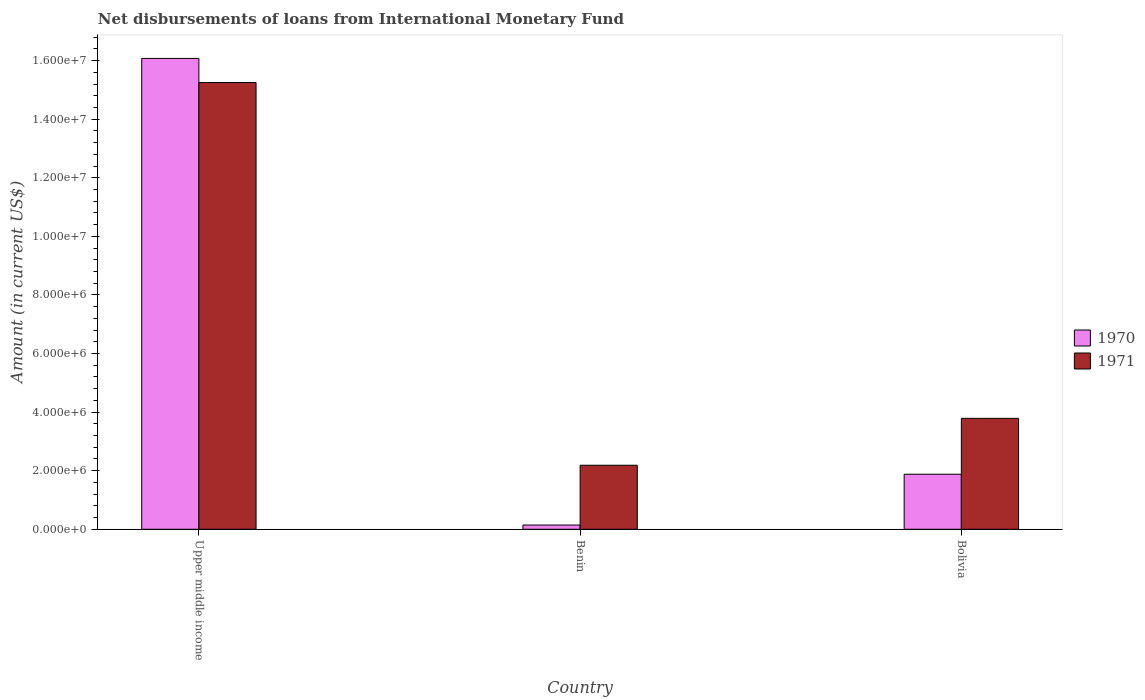How many different coloured bars are there?
Ensure brevity in your answer.  2. How many groups of bars are there?
Your response must be concise. 3. Are the number of bars per tick equal to the number of legend labels?
Keep it short and to the point. Yes. Are the number of bars on each tick of the X-axis equal?
Give a very brief answer. Yes. What is the label of the 3rd group of bars from the left?
Ensure brevity in your answer.  Bolivia. In how many cases, is the number of bars for a given country not equal to the number of legend labels?
Your answer should be compact. 0. What is the amount of loans disbursed in 1971 in Benin?
Make the answer very short. 2.19e+06. Across all countries, what is the maximum amount of loans disbursed in 1971?
Your answer should be compact. 1.52e+07. Across all countries, what is the minimum amount of loans disbursed in 1970?
Offer a terse response. 1.45e+05. In which country was the amount of loans disbursed in 1971 maximum?
Your answer should be compact. Upper middle income. In which country was the amount of loans disbursed in 1970 minimum?
Ensure brevity in your answer.  Benin. What is the total amount of loans disbursed in 1970 in the graph?
Offer a terse response. 1.81e+07. What is the difference between the amount of loans disbursed in 1970 in Bolivia and that in Upper middle income?
Make the answer very short. -1.42e+07. What is the difference between the amount of loans disbursed in 1970 in Upper middle income and the amount of loans disbursed in 1971 in Benin?
Offer a very short reply. 1.39e+07. What is the average amount of loans disbursed in 1970 per country?
Your answer should be very brief. 6.03e+06. What is the difference between the amount of loans disbursed of/in 1970 and amount of loans disbursed of/in 1971 in Bolivia?
Give a very brief answer. -1.91e+06. In how many countries, is the amount of loans disbursed in 1971 greater than 14800000 US$?
Give a very brief answer. 1. What is the ratio of the amount of loans disbursed in 1970 in Benin to that in Upper middle income?
Your response must be concise. 0.01. What is the difference between the highest and the second highest amount of loans disbursed in 1970?
Make the answer very short. 1.59e+07. What is the difference between the highest and the lowest amount of loans disbursed in 1970?
Offer a terse response. 1.59e+07. Is the sum of the amount of loans disbursed in 1971 in Benin and Upper middle income greater than the maximum amount of loans disbursed in 1970 across all countries?
Offer a terse response. Yes. What does the 2nd bar from the right in Bolivia represents?
Give a very brief answer. 1970. How many bars are there?
Give a very brief answer. 6. Are all the bars in the graph horizontal?
Give a very brief answer. No. What is the difference between two consecutive major ticks on the Y-axis?
Offer a terse response. 2.00e+06. Are the values on the major ticks of Y-axis written in scientific E-notation?
Your answer should be compact. Yes. Does the graph contain any zero values?
Your response must be concise. No. How many legend labels are there?
Your response must be concise. 2. What is the title of the graph?
Make the answer very short. Net disbursements of loans from International Monetary Fund. What is the label or title of the X-axis?
Your answer should be very brief. Country. What is the label or title of the Y-axis?
Provide a succinct answer. Amount (in current US$). What is the Amount (in current US$) of 1970 in Upper middle income?
Make the answer very short. 1.61e+07. What is the Amount (in current US$) of 1971 in Upper middle income?
Your answer should be compact. 1.52e+07. What is the Amount (in current US$) in 1970 in Benin?
Ensure brevity in your answer.  1.45e+05. What is the Amount (in current US$) of 1971 in Benin?
Keep it short and to the point. 2.19e+06. What is the Amount (in current US$) in 1970 in Bolivia?
Offer a very short reply. 1.88e+06. What is the Amount (in current US$) in 1971 in Bolivia?
Give a very brief answer. 3.79e+06. Across all countries, what is the maximum Amount (in current US$) of 1970?
Provide a short and direct response. 1.61e+07. Across all countries, what is the maximum Amount (in current US$) in 1971?
Your answer should be compact. 1.52e+07. Across all countries, what is the minimum Amount (in current US$) in 1970?
Offer a very short reply. 1.45e+05. Across all countries, what is the minimum Amount (in current US$) of 1971?
Your response must be concise. 2.19e+06. What is the total Amount (in current US$) of 1970 in the graph?
Make the answer very short. 1.81e+07. What is the total Amount (in current US$) in 1971 in the graph?
Make the answer very short. 2.12e+07. What is the difference between the Amount (in current US$) of 1970 in Upper middle income and that in Benin?
Your answer should be compact. 1.59e+07. What is the difference between the Amount (in current US$) of 1971 in Upper middle income and that in Benin?
Your answer should be compact. 1.31e+07. What is the difference between the Amount (in current US$) of 1970 in Upper middle income and that in Bolivia?
Make the answer very short. 1.42e+07. What is the difference between the Amount (in current US$) in 1971 in Upper middle income and that in Bolivia?
Your answer should be compact. 1.15e+07. What is the difference between the Amount (in current US$) of 1970 in Benin and that in Bolivia?
Your answer should be compact. -1.73e+06. What is the difference between the Amount (in current US$) of 1971 in Benin and that in Bolivia?
Your answer should be very brief. -1.60e+06. What is the difference between the Amount (in current US$) in 1970 in Upper middle income and the Amount (in current US$) in 1971 in Benin?
Your answer should be very brief. 1.39e+07. What is the difference between the Amount (in current US$) of 1970 in Upper middle income and the Amount (in current US$) of 1971 in Bolivia?
Offer a terse response. 1.23e+07. What is the difference between the Amount (in current US$) in 1970 in Benin and the Amount (in current US$) in 1971 in Bolivia?
Give a very brief answer. -3.64e+06. What is the average Amount (in current US$) of 1970 per country?
Provide a succinct answer. 6.03e+06. What is the average Amount (in current US$) in 1971 per country?
Your response must be concise. 7.07e+06. What is the difference between the Amount (in current US$) of 1970 and Amount (in current US$) of 1971 in Upper middle income?
Provide a succinct answer. 8.24e+05. What is the difference between the Amount (in current US$) of 1970 and Amount (in current US$) of 1971 in Benin?
Provide a short and direct response. -2.04e+06. What is the difference between the Amount (in current US$) of 1970 and Amount (in current US$) of 1971 in Bolivia?
Make the answer very short. -1.91e+06. What is the ratio of the Amount (in current US$) of 1970 in Upper middle income to that in Benin?
Your answer should be compact. 110.86. What is the ratio of the Amount (in current US$) of 1971 in Upper middle income to that in Benin?
Give a very brief answer. 6.98. What is the ratio of the Amount (in current US$) of 1970 in Upper middle income to that in Bolivia?
Ensure brevity in your answer.  8.55. What is the ratio of the Amount (in current US$) of 1971 in Upper middle income to that in Bolivia?
Your response must be concise. 4.03. What is the ratio of the Amount (in current US$) in 1970 in Benin to that in Bolivia?
Your response must be concise. 0.08. What is the ratio of the Amount (in current US$) of 1971 in Benin to that in Bolivia?
Keep it short and to the point. 0.58. What is the difference between the highest and the second highest Amount (in current US$) of 1970?
Your response must be concise. 1.42e+07. What is the difference between the highest and the second highest Amount (in current US$) of 1971?
Provide a short and direct response. 1.15e+07. What is the difference between the highest and the lowest Amount (in current US$) of 1970?
Provide a short and direct response. 1.59e+07. What is the difference between the highest and the lowest Amount (in current US$) in 1971?
Your answer should be compact. 1.31e+07. 